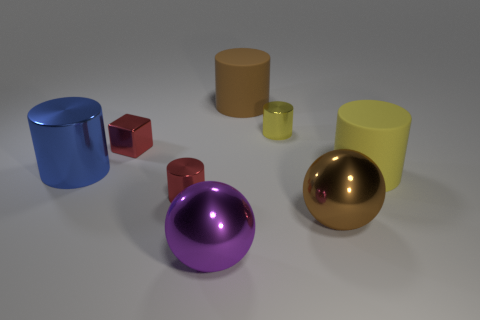Subtract all cylinders. How many objects are left? 3 Subtract 3 cylinders. How many cylinders are left? 2 Subtract all gray cylinders. Subtract all gray blocks. How many cylinders are left? 5 Subtract all brown cubes. How many yellow cylinders are left? 2 Subtract all red cylinders. Subtract all large cylinders. How many objects are left? 4 Add 2 big yellow cylinders. How many big yellow cylinders are left? 3 Add 1 brown balls. How many brown balls exist? 2 Add 1 blue things. How many objects exist? 9 Subtract all brown cylinders. How many cylinders are left? 4 Subtract all big blue cylinders. How many cylinders are left? 4 